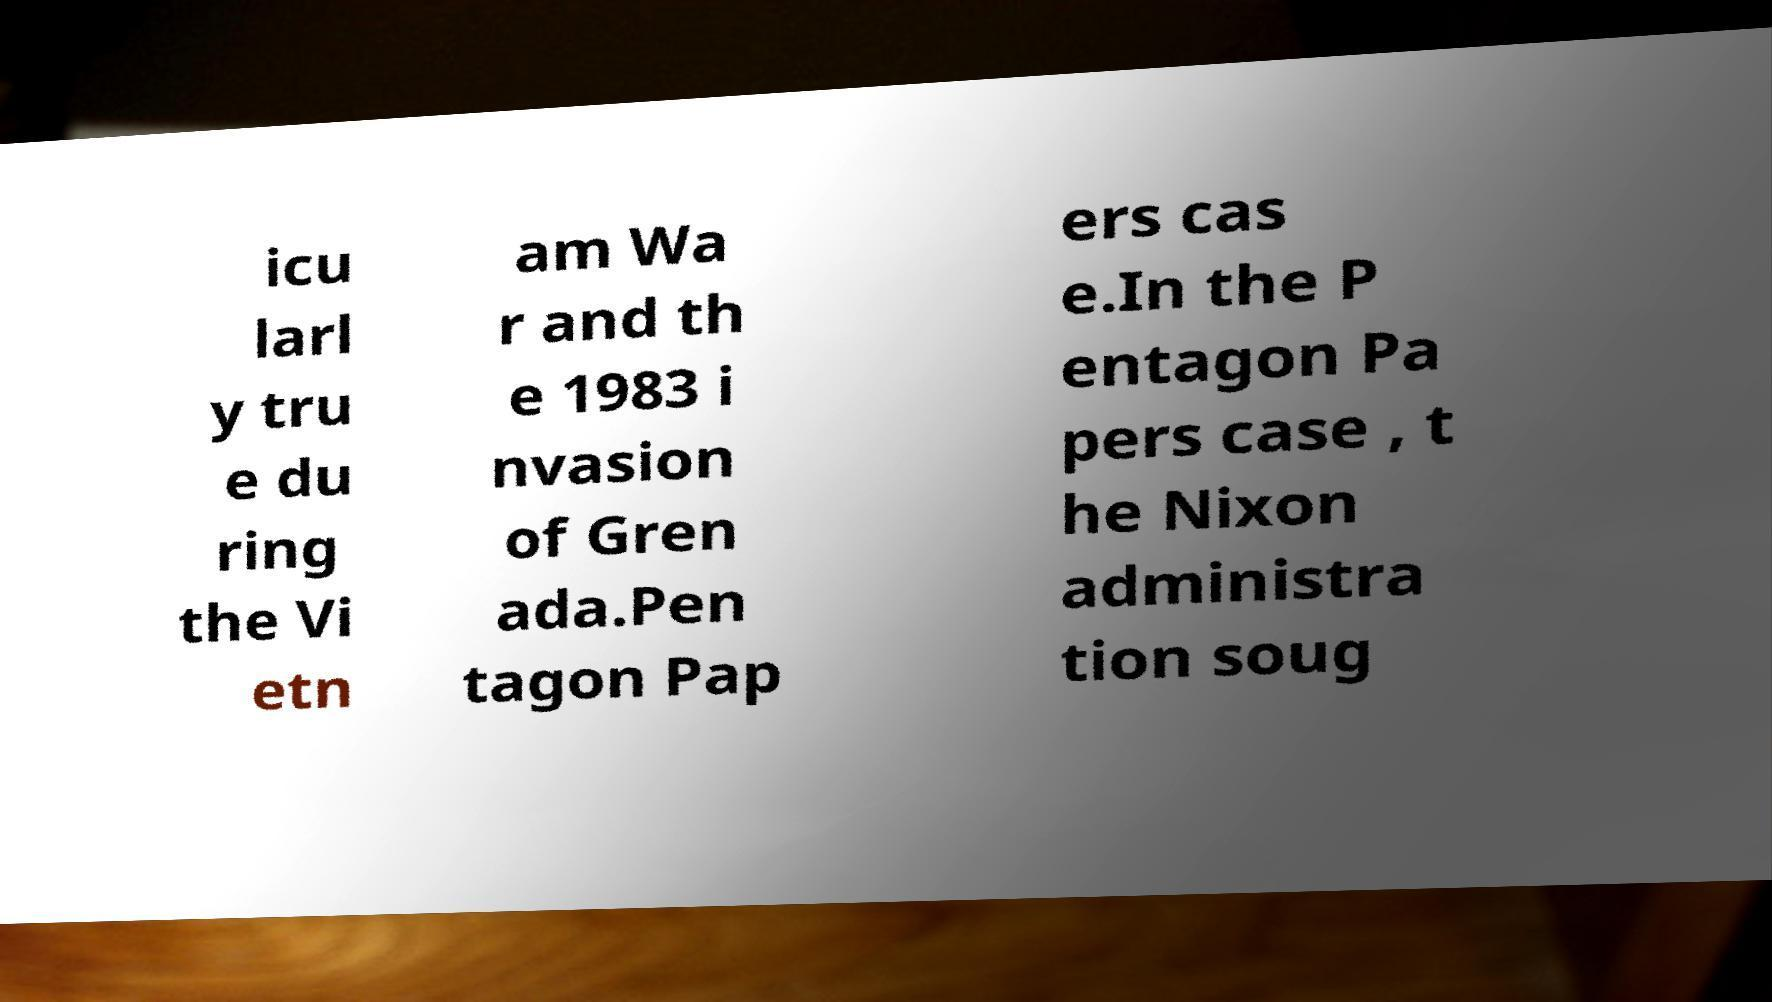Could you assist in decoding the text presented in this image and type it out clearly? icu larl y tru e du ring the Vi etn am Wa r and th e 1983 i nvasion of Gren ada.Pen tagon Pap ers cas e.In the P entagon Pa pers case , t he Nixon administra tion soug 